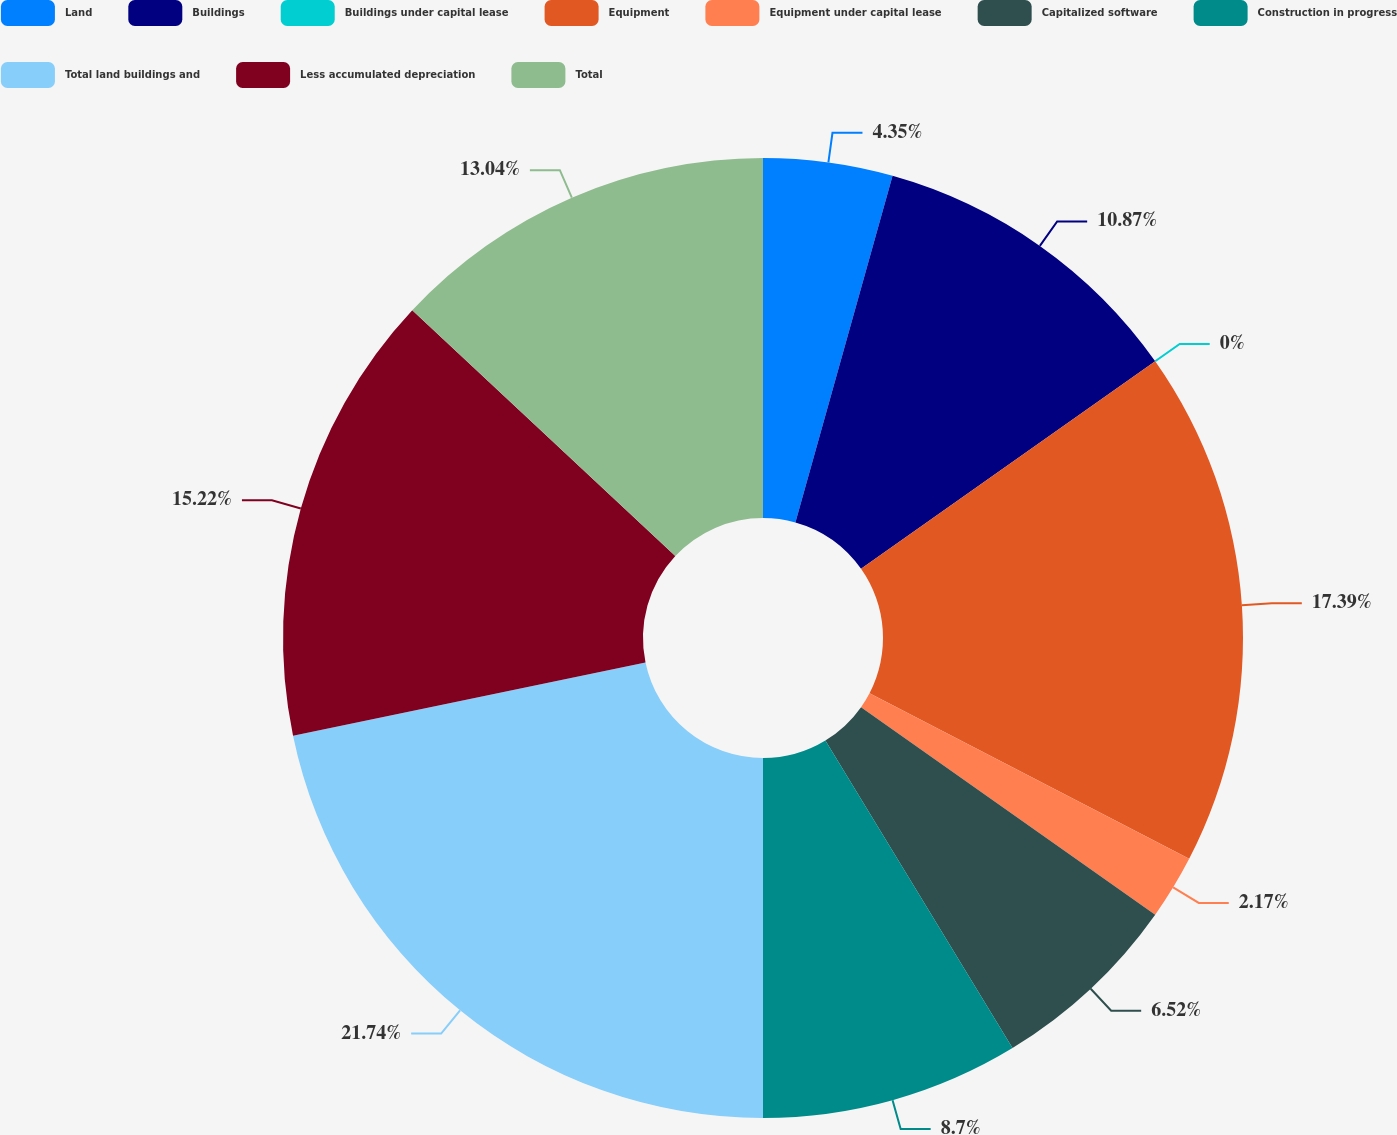<chart> <loc_0><loc_0><loc_500><loc_500><pie_chart><fcel>Land<fcel>Buildings<fcel>Buildings under capital lease<fcel>Equipment<fcel>Equipment under capital lease<fcel>Capitalized software<fcel>Construction in progress<fcel>Total land buildings and<fcel>Less accumulated depreciation<fcel>Total<nl><fcel>4.35%<fcel>10.87%<fcel>0.0%<fcel>17.39%<fcel>2.17%<fcel>6.52%<fcel>8.7%<fcel>21.74%<fcel>15.22%<fcel>13.04%<nl></chart> 